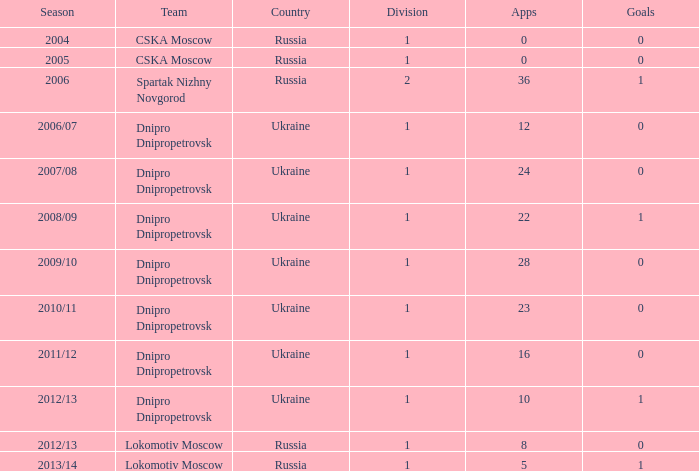What division was Ukraine in 2006/07? 1.0. 